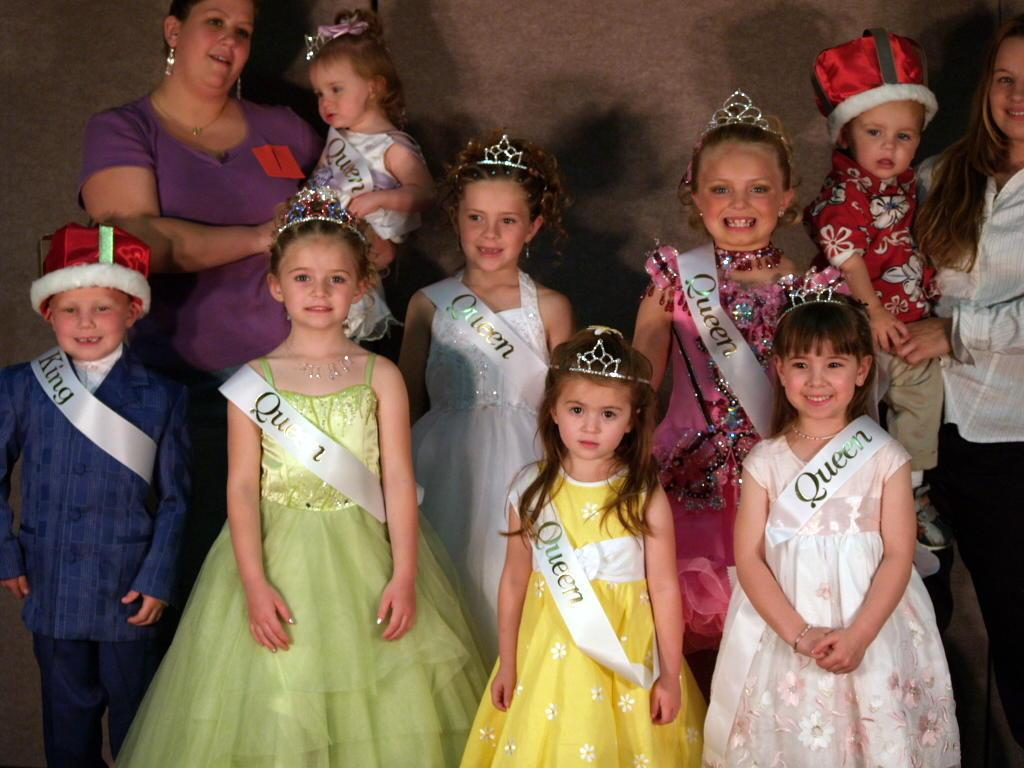What can be seen in the image? There are children and two women standing in the image. What are the women doing in the image? The women are holding kids in their hands. What is visible in the background of the image? There is a wall visible in the background of the image. What type of crate is being used to transport the disease in the image? There is no crate or disease present in the image. 